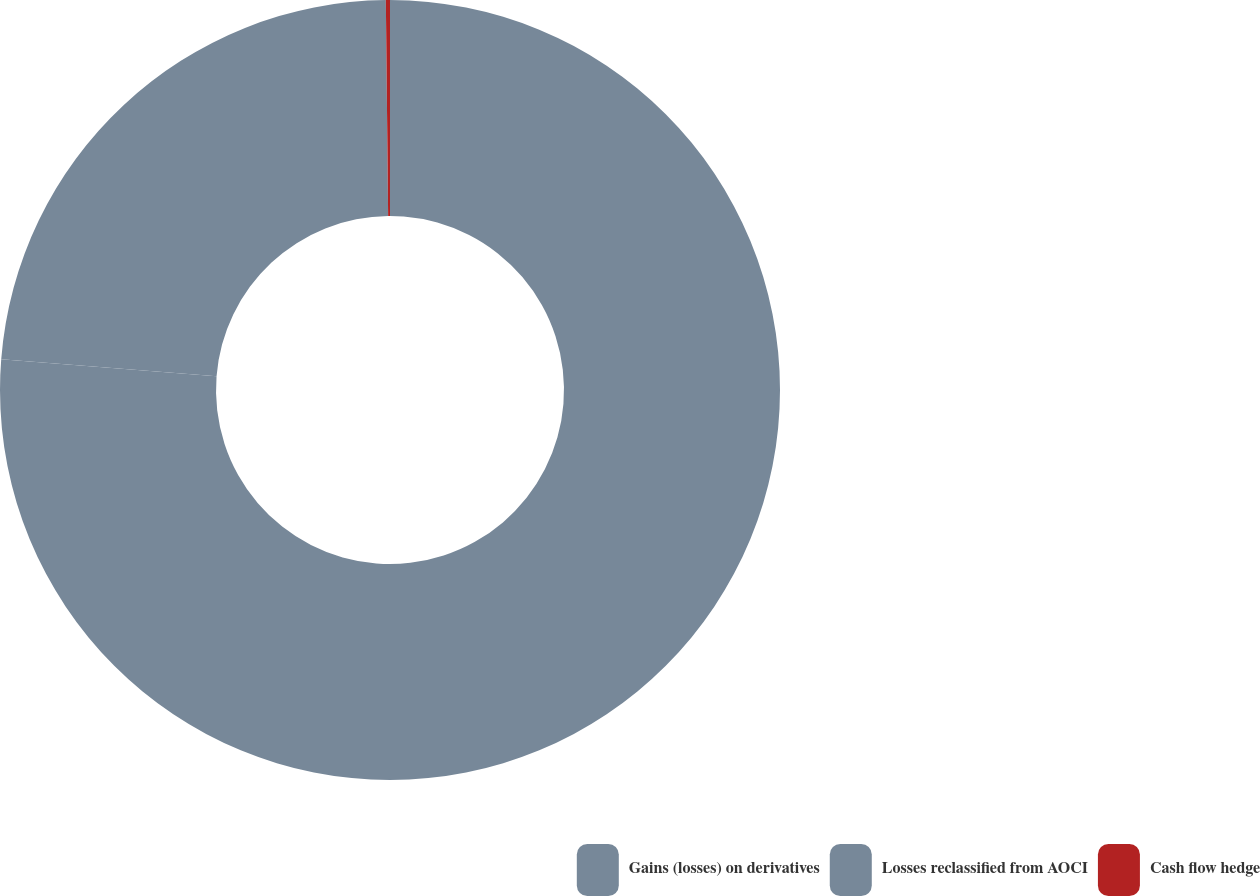Convert chart. <chart><loc_0><loc_0><loc_500><loc_500><pie_chart><fcel>Gains (losses) on derivatives<fcel>Losses reclassified from AOCI<fcel>Cash flow hedge<nl><fcel>76.26%<fcel>23.57%<fcel>0.17%<nl></chart> 